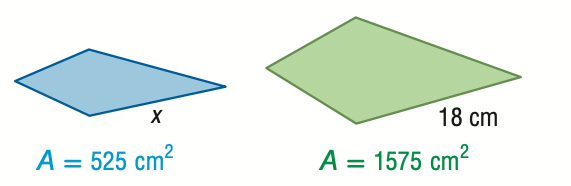Answer the mathemtical geometry problem and directly provide the correct option letter.
Question: For the pair of similar figures, use the given areas to find the scale factor from the blue to the green figure.
Choices: A: \frac { 1 } { 3 } B: \frac { 1 } { \sqrt { 3 } } C: \frac { \sqrt { 3 } } { 1 } D: \frac { 3 } { 1 } B 